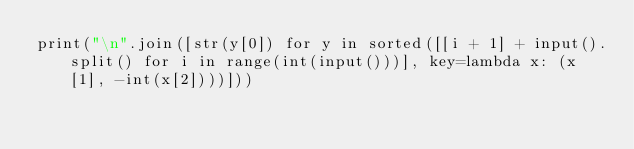<code> <loc_0><loc_0><loc_500><loc_500><_Python_>print("\n".join([str(y[0]) for y in sorted([[i + 1] + input().split() for i in range(int(input()))], key=lambda x: (x[1], -int(x[2])))]))
</code> 